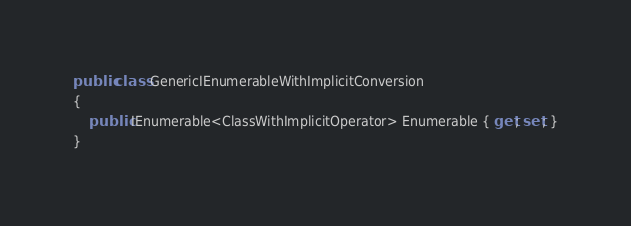<code> <loc_0><loc_0><loc_500><loc_500><_C#_>
public class GenericIEnumerableWithImplicitConversion
{
    public IEnumerable<ClassWithImplicitOperator> Enumerable { get; set; }
}</code> 